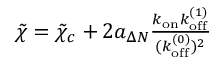<formula> <loc_0><loc_0><loc_500><loc_500>\begin{array} { r } { \tilde { \chi } = \tilde { \chi } _ { c } + 2 a _ { \Delta N } \frac { k _ { o n } k _ { o f f } ^ { ( 1 ) } } { ( k _ { o f f } ^ { ( 0 ) } ) ^ { 2 } } } \end{array}</formula> 